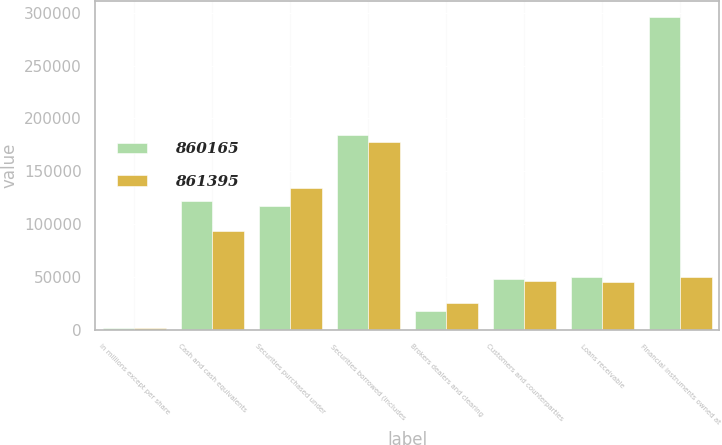Convert chart to OTSL. <chart><loc_0><loc_0><loc_500><loc_500><stacked_bar_chart><ecel><fcel>in millions except per share<fcel>Cash and cash equivalents<fcel>Securities purchased under<fcel>Securities borrowed (includes<fcel>Brokers dealers and clearing<fcel>Customers and counterparties<fcel>Loans receivable<fcel>Financial instruments owned at<nl><fcel>860165<fcel>2016<fcel>121711<fcel>116925<fcel>184600<fcel>18044<fcel>47780<fcel>49672<fcel>295952<nl><fcel>861395<fcel>2015<fcel>93439<fcel>134308<fcel>177638<fcel>25453<fcel>46430<fcel>45407<fcel>49672<nl></chart> 